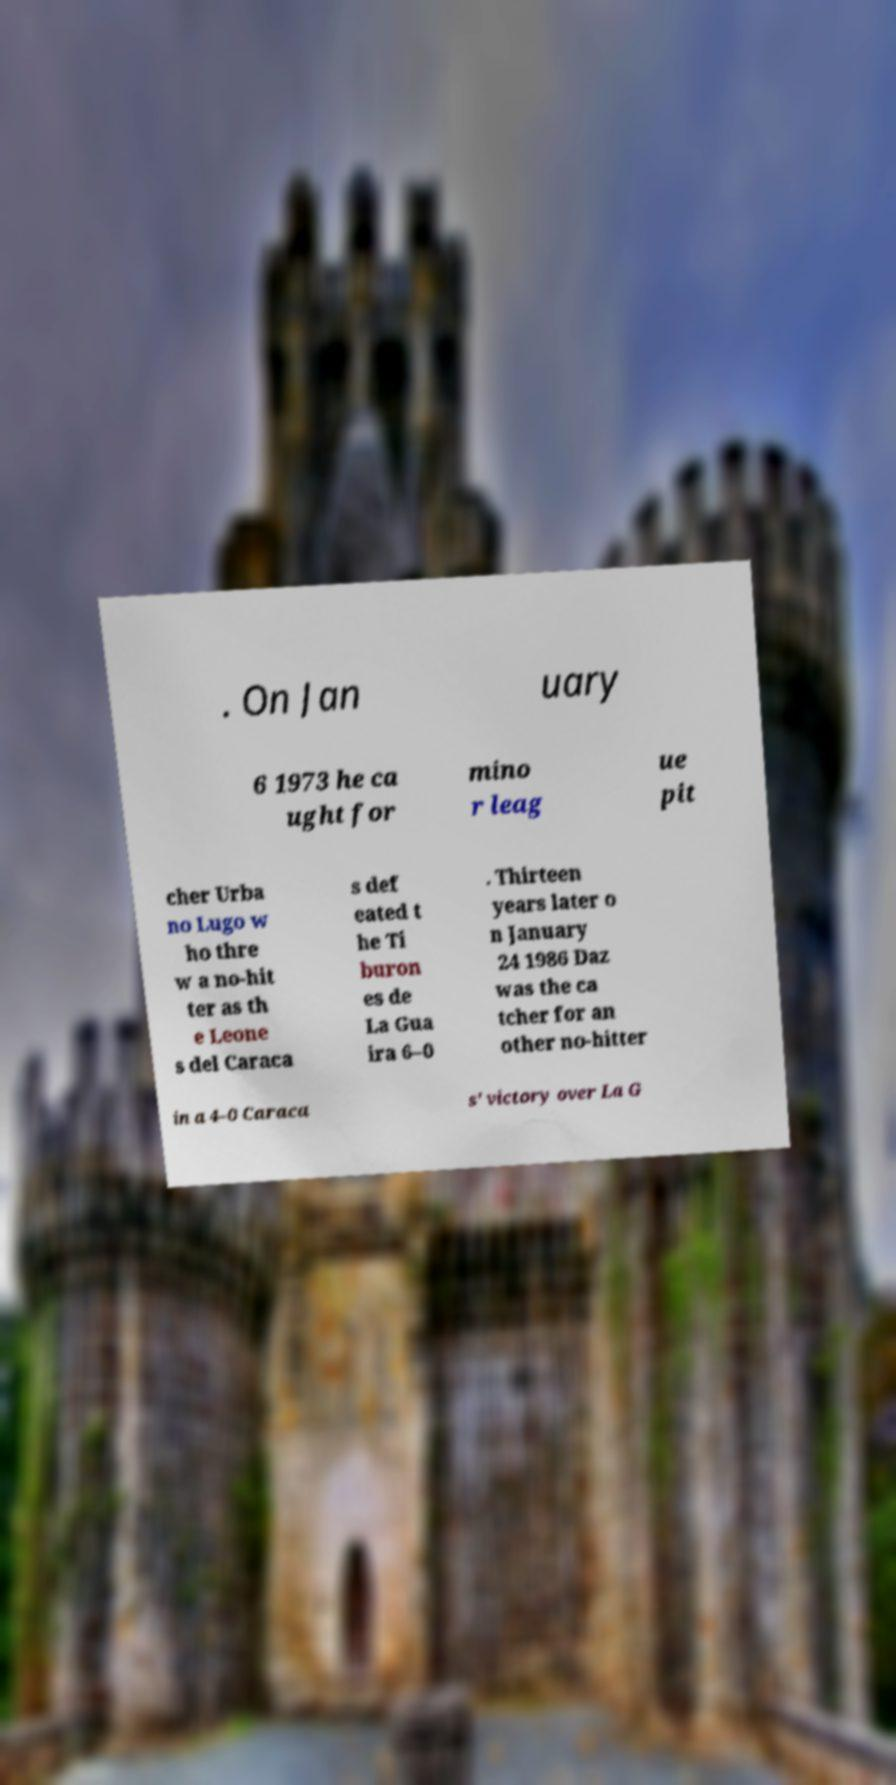Could you extract and type out the text from this image? . On Jan uary 6 1973 he ca ught for mino r leag ue pit cher Urba no Lugo w ho thre w a no-hit ter as th e Leone s del Caraca s def eated t he Ti buron es de La Gua ira 6–0 . Thirteen years later o n January 24 1986 Daz was the ca tcher for an other no-hitter in a 4–0 Caraca s' victory over La G 